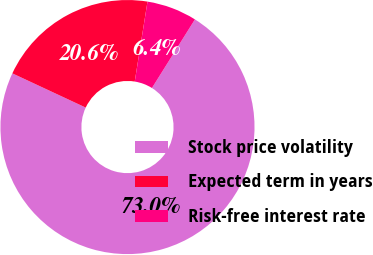Convert chart. <chart><loc_0><loc_0><loc_500><loc_500><pie_chart><fcel>Stock price volatility<fcel>Expected term in years<fcel>Risk-free interest rate<nl><fcel>73.03%<fcel>20.57%<fcel>6.39%<nl></chart> 